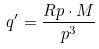<formula> <loc_0><loc_0><loc_500><loc_500>q ^ { \prime } = \frac { R p \cdot M } { p ^ { 3 } }</formula> 